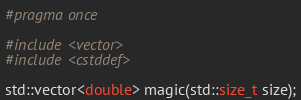Convert code to text. <code><loc_0><loc_0><loc_500><loc_500><_C++_>#pragma once

#include <vector>
#include <cstddef>

std::vector<double> magic(std::size_t size);
</code> 